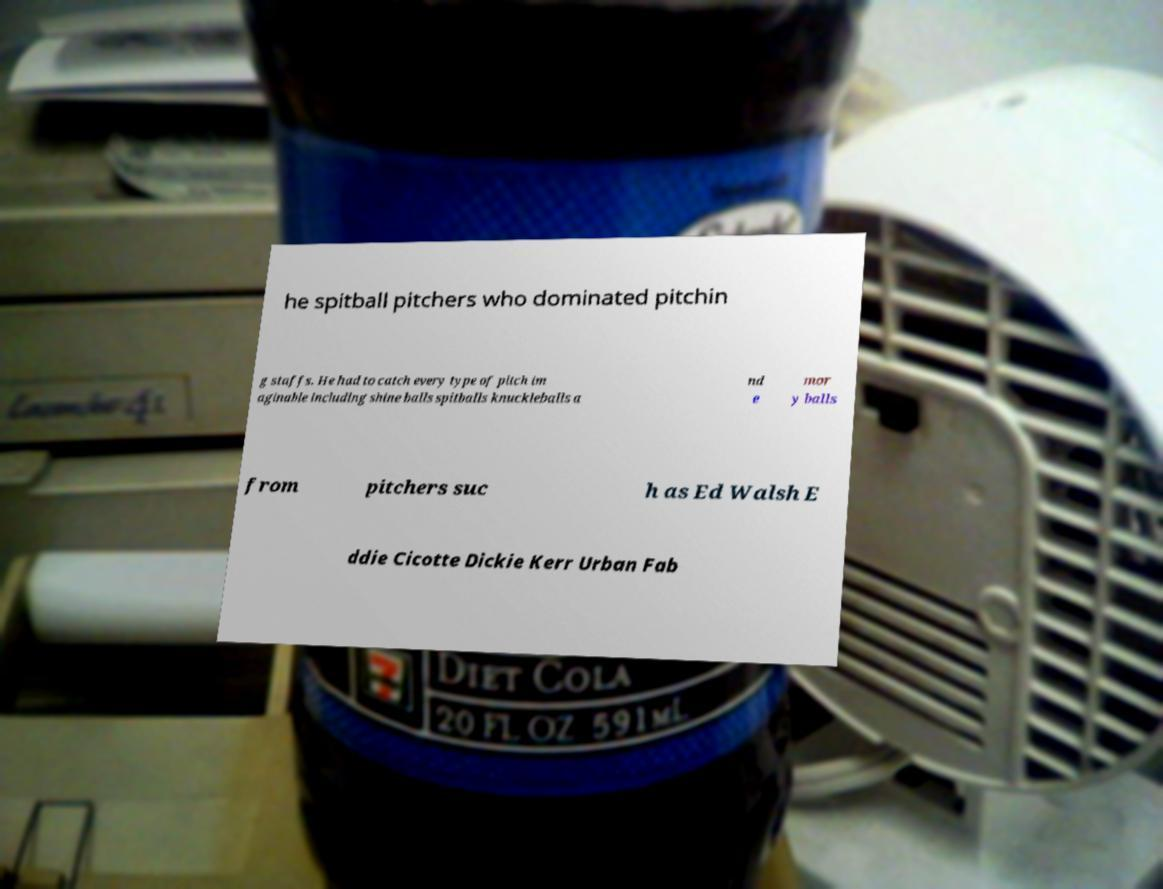Could you extract and type out the text from this image? he spitball pitchers who dominated pitchin g staffs. He had to catch every type of pitch im aginable including shine balls spitballs knuckleballs a nd e mor y balls from pitchers suc h as Ed Walsh E ddie Cicotte Dickie Kerr Urban Fab 